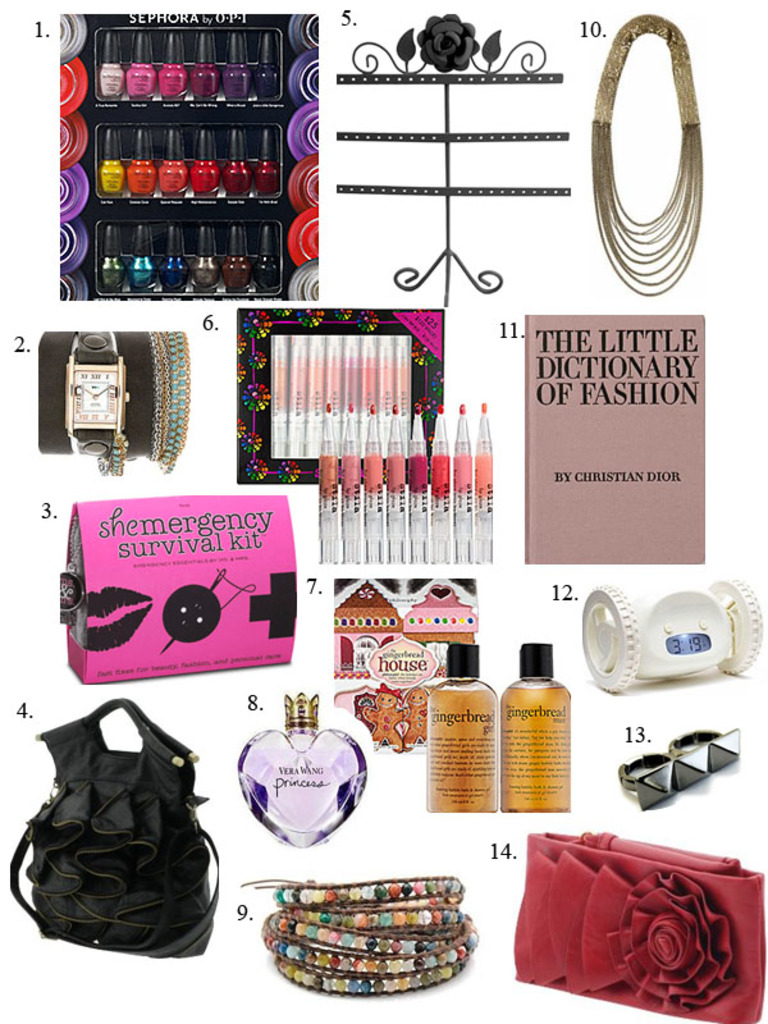Provide a one-sentence caption for the provided image. The image displays a variety of fashion and beauty accessories including a colorful nail polish set by Sephora, a stylish handbag, chic jewelry, and 'The Little Dictionary of Fashion' by Christian Dior, making it a collage of personal style essentials. 